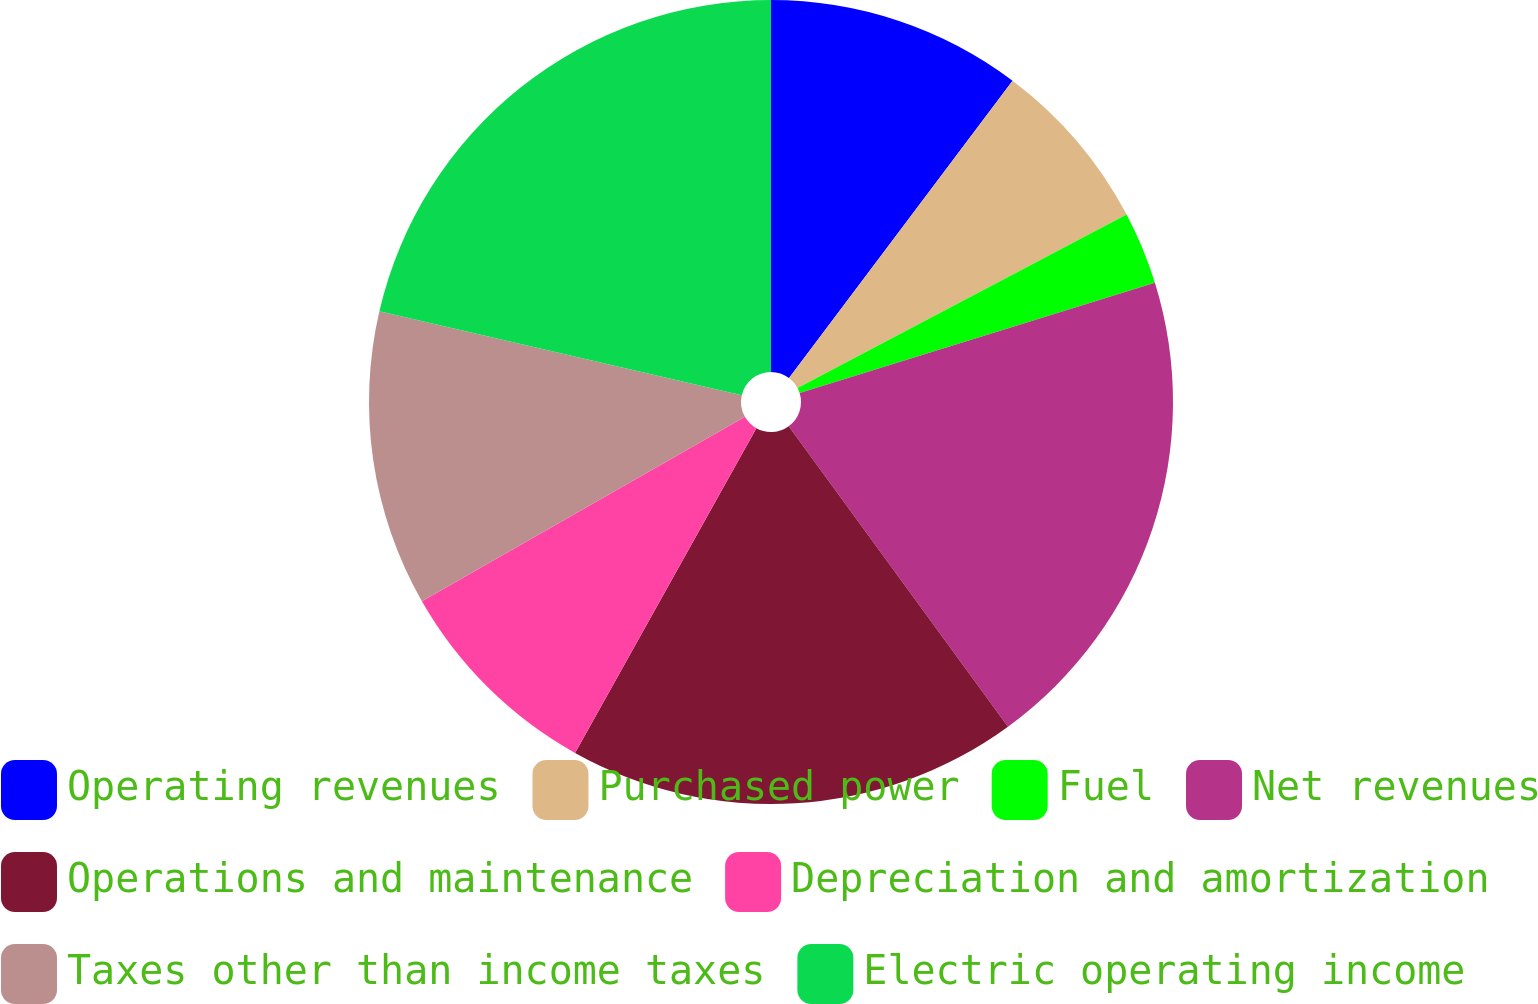Convert chart. <chart><loc_0><loc_0><loc_500><loc_500><pie_chart><fcel>Operating revenues<fcel>Purchased power<fcel>Fuel<fcel>Net revenues<fcel>Operations and maintenance<fcel>Depreciation and amortization<fcel>Taxes other than income taxes<fcel>Electric operating income<nl><fcel>10.26%<fcel>7.02%<fcel>2.93%<fcel>19.76%<fcel>18.14%<fcel>8.64%<fcel>11.88%<fcel>21.38%<nl></chart> 